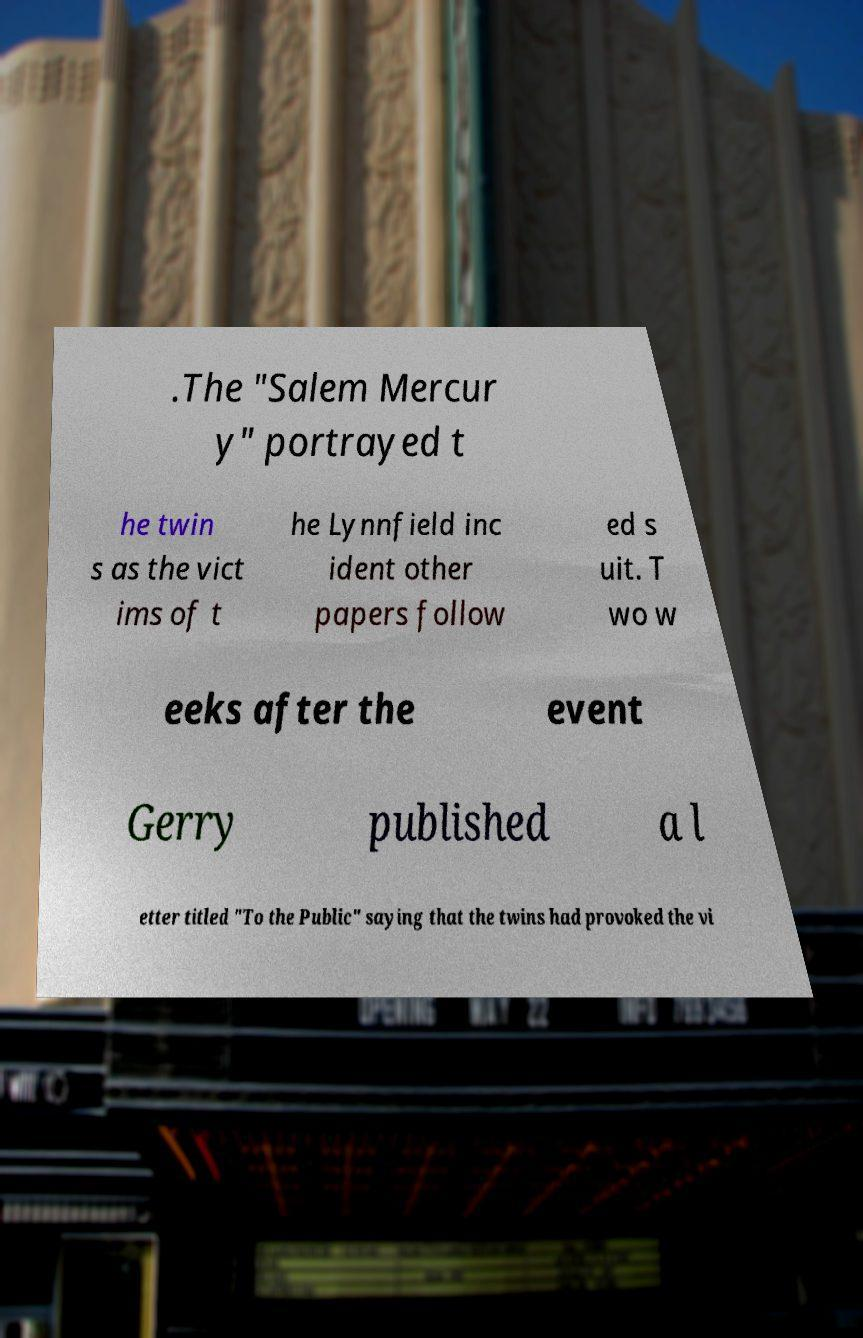What messages or text are displayed in this image? I need them in a readable, typed format. .The "Salem Mercur y" portrayed t he twin s as the vict ims of t he Lynnfield inc ident other papers follow ed s uit. T wo w eeks after the event Gerry published a l etter titled "To the Public" saying that the twins had provoked the vi 